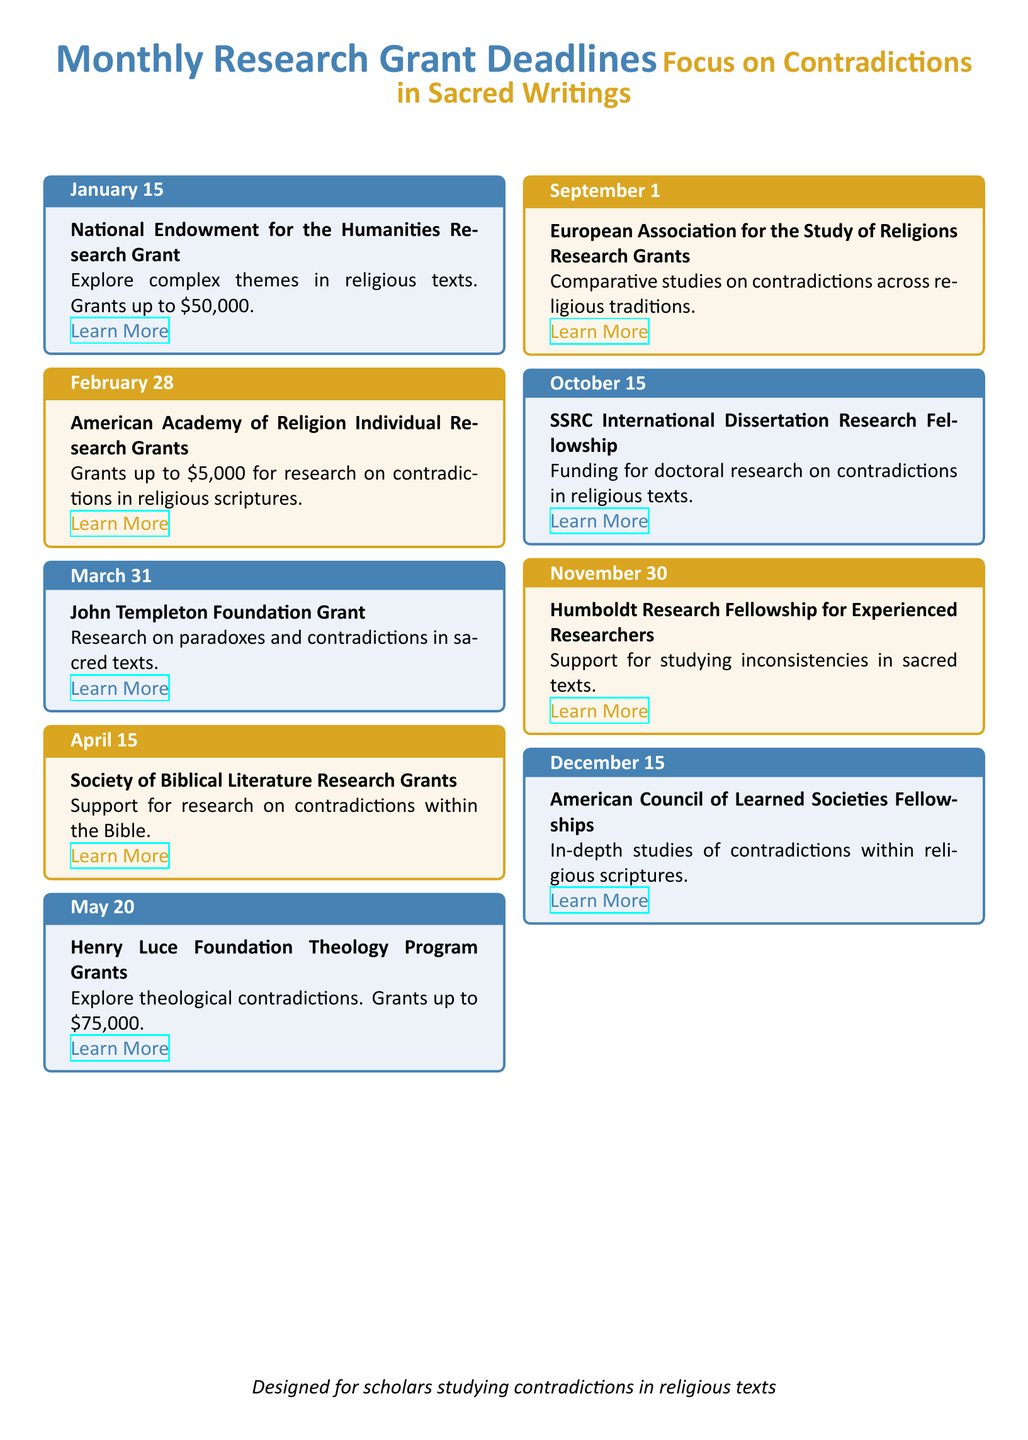What is the deadline for the National Endowment for the Humanities Research Grant? The document states that the deadline is January 15.
Answer: January 15 What is the maximum grant amount for the Henry Luce Foundation Theology Program Grants? The document specifies that the maximum grant amount is $75,000.
Answer: $75,000 Which grant focuses on research concerning contradictions within the Bible? The document mentions the Society of Biblical Literature Research Grants for this purpose.
Answer: Society of Biblical Literature Research Grants How many grants are available for studying contradictions in religious scriptures? The document lists multiple grants focused on studying contradictions, including the American Academy of Religion and the Society of Biblical Literature grants, making it several grants available.
Answer: Several What type of studies does the European Association for the Study of Religions Research Grants support? The document states that these grants support comparative studies on contradictions.
Answer: Comparative studies What is the application deadline for the American Council of Learned Societies Fellowships? The document indicates that the deadline is December 15.
Answer: December 15 What is the primary focus of the John Templeton Foundation Grant? According to the document, it focuses on research on paradoxes and contradictions in sacred texts.
Answer: Research on paradoxes and contradictions Which month features the Henry Luce Foundation Theology Program Grants? The document lists May as the month for this grant.
Answer: May 